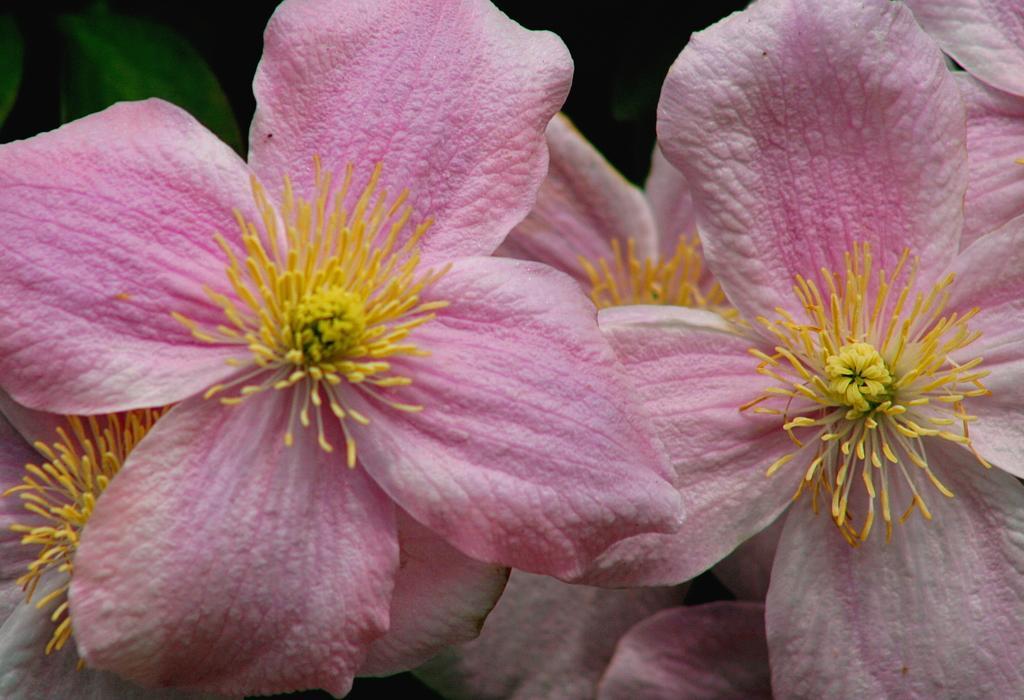Can you describe this image briefly? In this image there are beautiful flowers. 